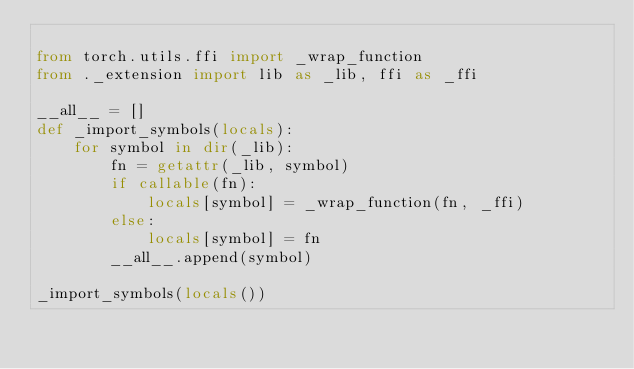<code> <loc_0><loc_0><loc_500><loc_500><_Python_>
from torch.utils.ffi import _wrap_function
from ._extension import lib as _lib, ffi as _ffi

__all__ = []
def _import_symbols(locals):
    for symbol in dir(_lib):
        fn = getattr(_lib, symbol)
        if callable(fn):
            locals[symbol] = _wrap_function(fn, _ffi)
        else:
            locals[symbol] = fn
        __all__.append(symbol)

_import_symbols(locals())
</code> 